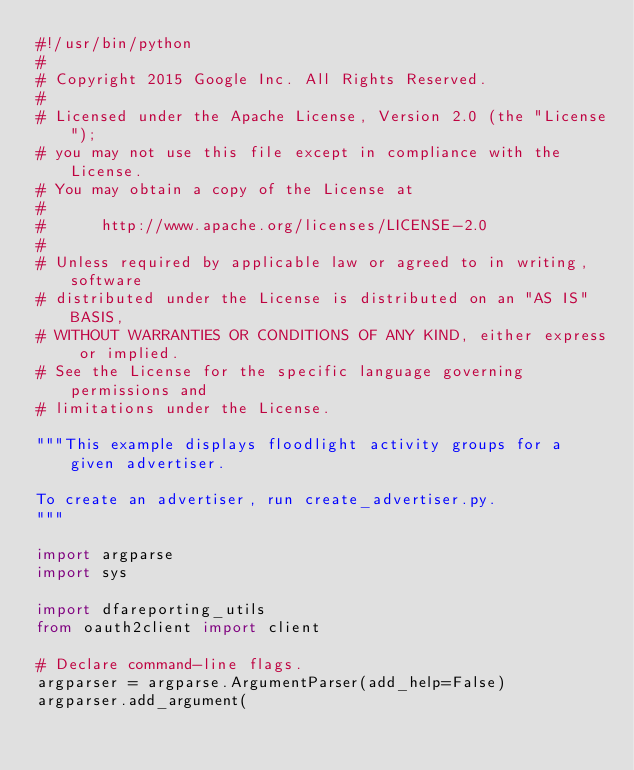<code> <loc_0><loc_0><loc_500><loc_500><_Python_>#!/usr/bin/python
#
# Copyright 2015 Google Inc. All Rights Reserved.
#
# Licensed under the Apache License, Version 2.0 (the "License");
# you may not use this file except in compliance with the License.
# You may obtain a copy of the License at
#
#      http://www.apache.org/licenses/LICENSE-2.0
#
# Unless required by applicable law or agreed to in writing, software
# distributed under the License is distributed on an "AS IS" BASIS,
# WITHOUT WARRANTIES OR CONDITIONS OF ANY KIND, either express or implied.
# See the License for the specific language governing permissions and
# limitations under the License.

"""This example displays floodlight activity groups for a given advertiser.

To create an advertiser, run create_advertiser.py.
"""

import argparse
import sys

import dfareporting_utils
from oauth2client import client

# Declare command-line flags.
argparser = argparse.ArgumentParser(add_help=False)
argparser.add_argument(</code> 